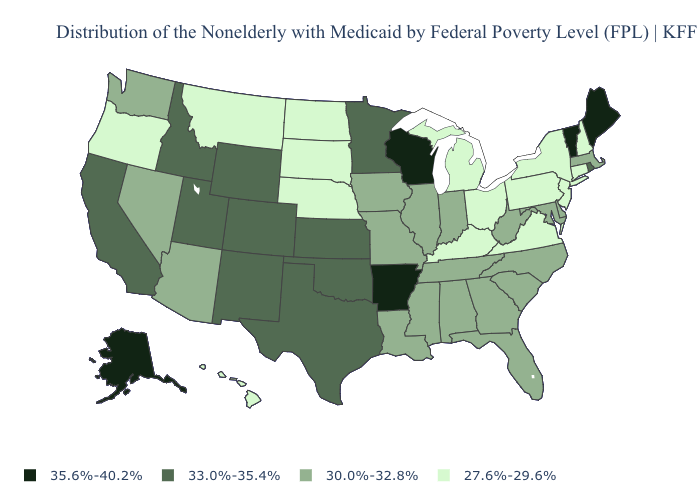Name the states that have a value in the range 35.6%-40.2%?
Short answer required. Alaska, Arkansas, Maine, Vermont, Wisconsin. Name the states that have a value in the range 33.0%-35.4%?
Give a very brief answer. California, Colorado, Idaho, Kansas, Minnesota, New Mexico, Oklahoma, Rhode Island, Texas, Utah, Wyoming. Does Rhode Island have the same value as Louisiana?
Be succinct. No. What is the value of Iowa?
Quick response, please. 30.0%-32.8%. Name the states that have a value in the range 35.6%-40.2%?
Answer briefly. Alaska, Arkansas, Maine, Vermont, Wisconsin. What is the value of Nevada?
Keep it brief. 30.0%-32.8%. What is the value of Wyoming?
Short answer required. 33.0%-35.4%. What is the value of Arizona?
Keep it brief. 30.0%-32.8%. Among the states that border New Hampshire , does Massachusetts have the highest value?
Answer briefly. No. Does Maine have the same value as Arkansas?
Short answer required. Yes. What is the value of New Hampshire?
Give a very brief answer. 27.6%-29.6%. What is the lowest value in states that border New Hampshire?
Answer briefly. 30.0%-32.8%. Does Utah have the lowest value in the USA?
Short answer required. No. What is the highest value in the USA?
Answer briefly. 35.6%-40.2%. Which states have the lowest value in the USA?
Write a very short answer. Connecticut, Hawaii, Kentucky, Michigan, Montana, Nebraska, New Hampshire, New Jersey, New York, North Dakota, Ohio, Oregon, Pennsylvania, South Dakota, Virginia. 